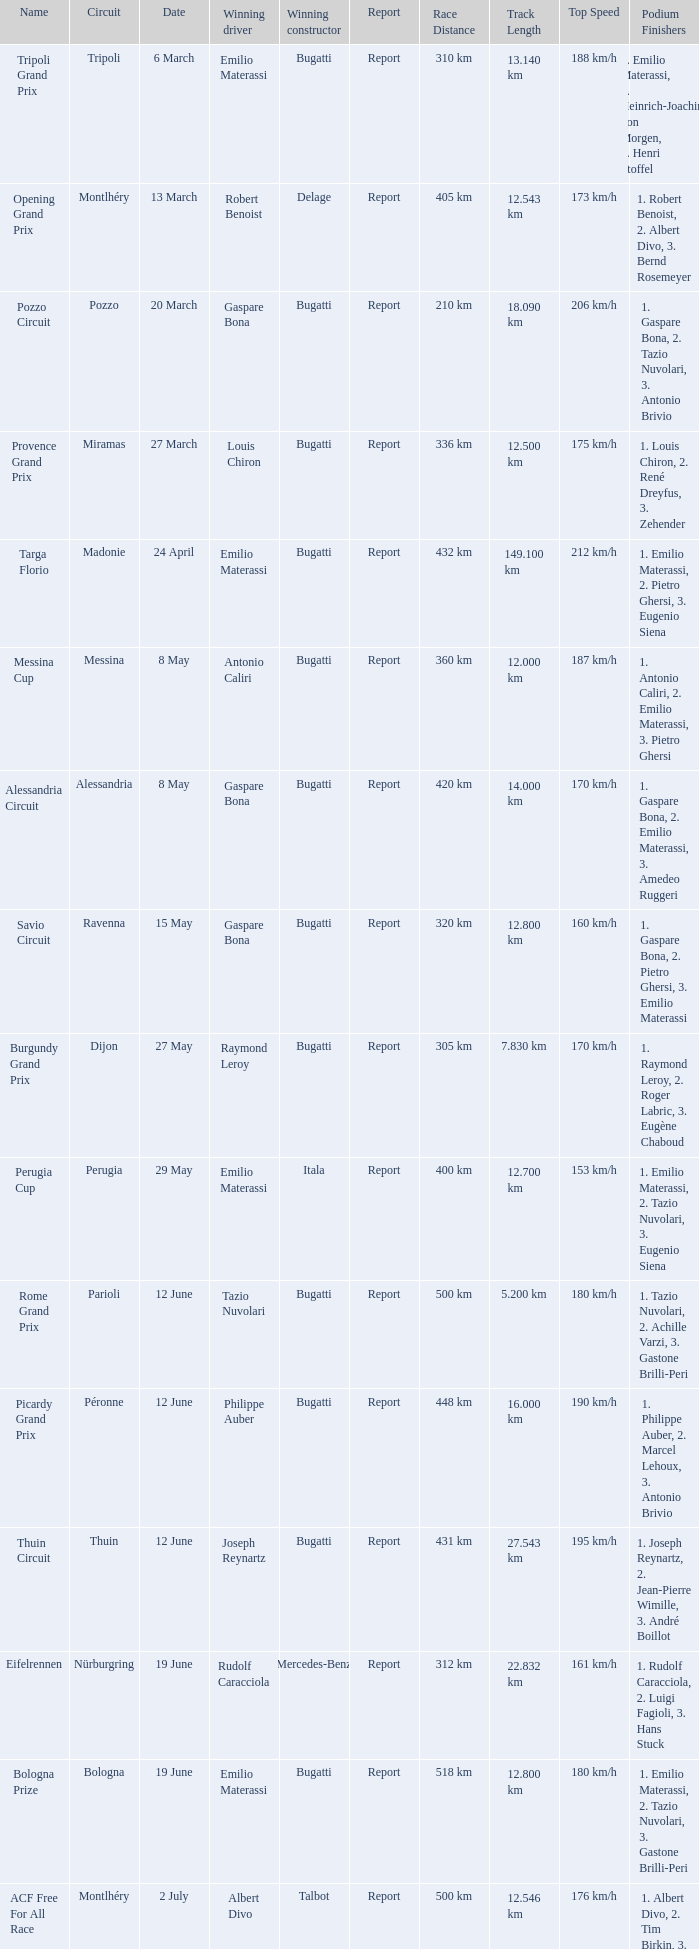Which circuit did françois eysermann win ? Saint-Gaudens. 